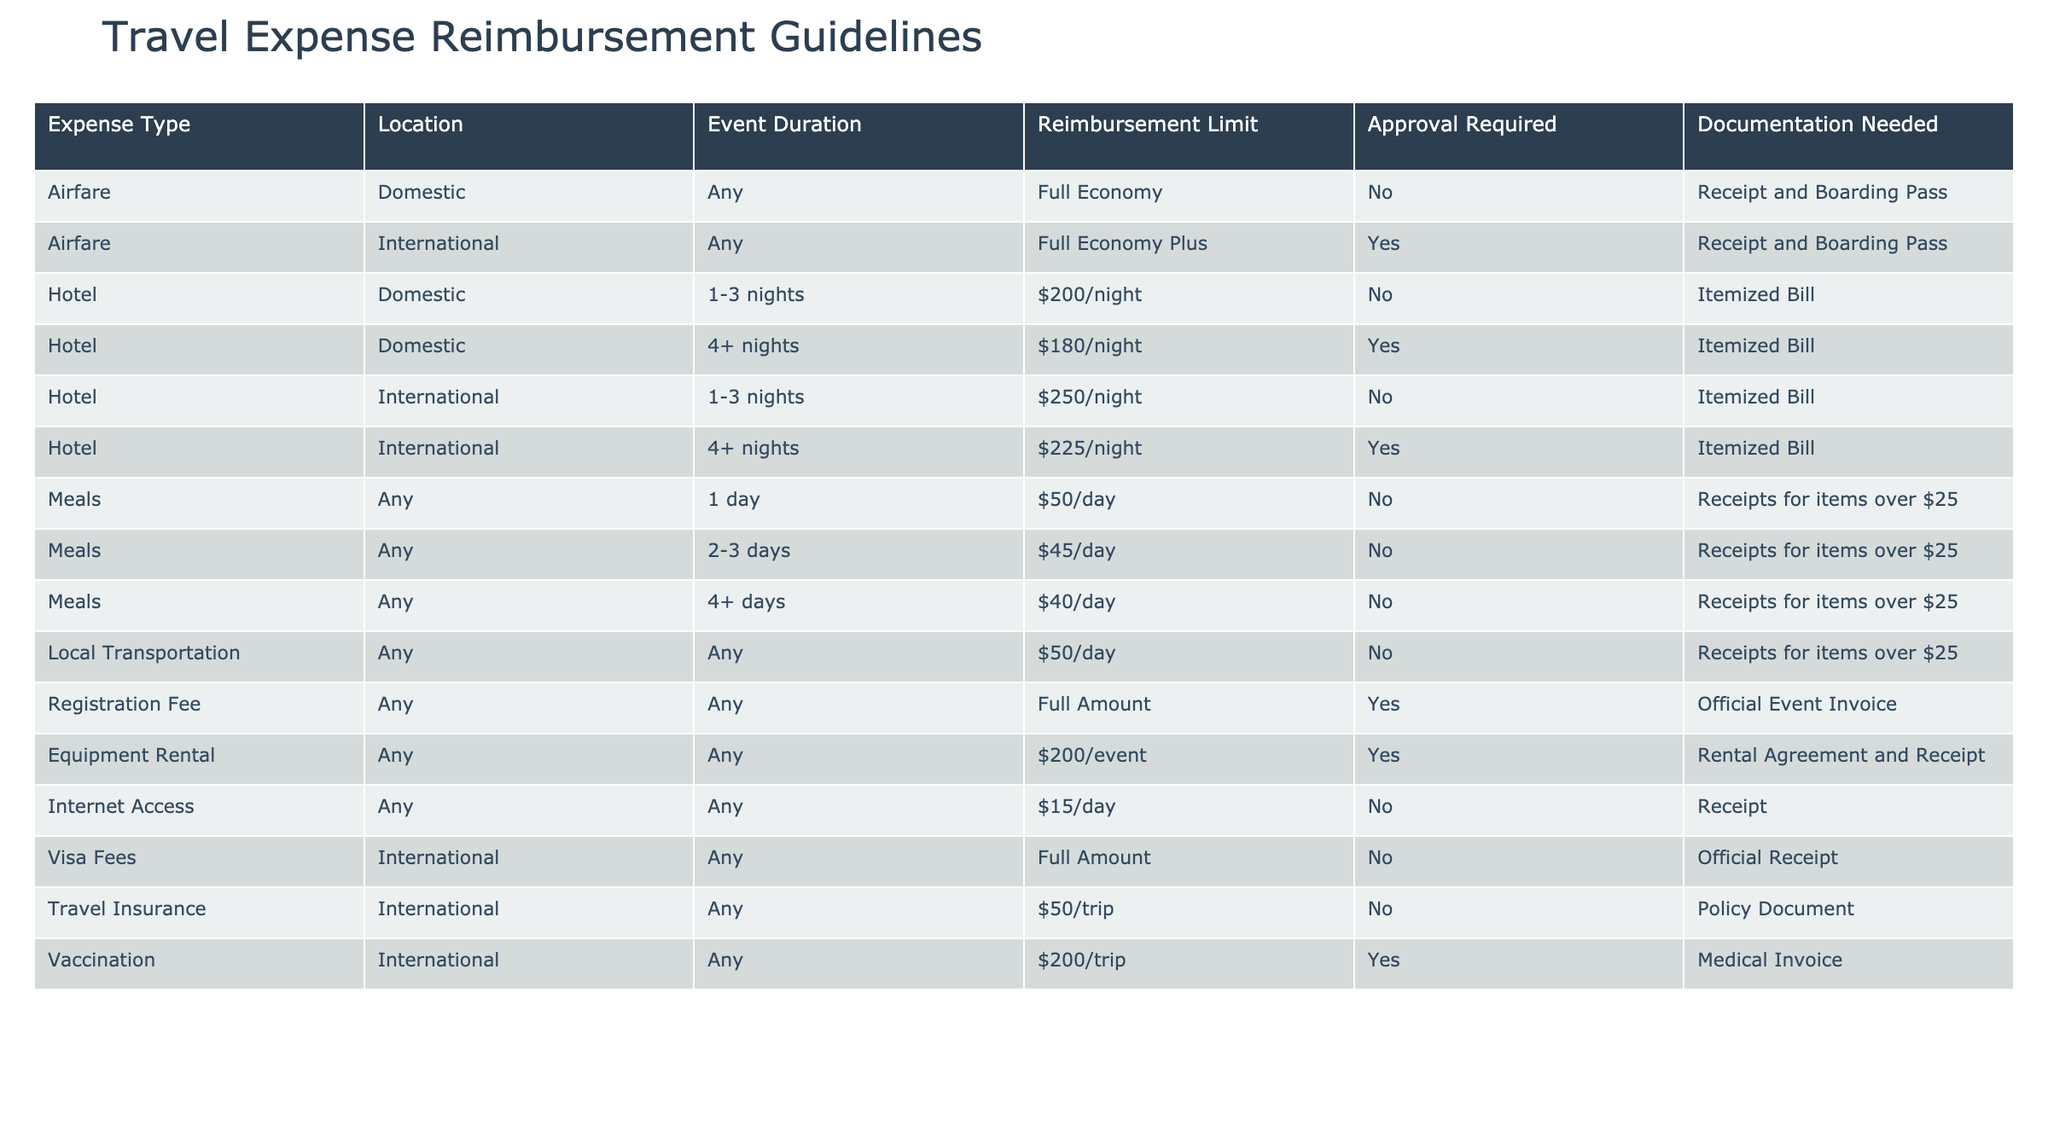What is the maximum reimbursement limit for airfare on domestic flights? According to the table, the reimbursement limit for domestic airfare is "Full Economy" for any duration. Therefore, this is the maximum reimbursement limit.
Answer: Full Economy Is approval required for hotel expenses incurred during a stay of 5 nights domestically? The table states that for hotel stays of 4+ nights domestically, approval is required. Since 5 nights falls into this category, approval is indeed required.
Answer: Yes What is the reimbursement limit for meals over a duration of 3 days? The table outlines that for meals lasting 2-3 days, the limit is $45 per day, and for meals lasting 4 or more days, the limit is $40 per day. Therefore, for a duration of 3 days, the appropriate limit is $45.
Answer: $45/day If a coder attends an international event for 2 days, what is the total maximum reimbursement for meals? The table shows that for any duration of 1 day, the reimbursement limit is $50/day. Since for 2-3 days it is $45/day, the maximum reimbursement for meals over 2 days is $45 times 2, which equals $90.
Answer: $90 Is documentation needed for local transportation expenses? The table specifies that local transportation has a reimbursement limit of $50/day and does not require specific approval or documentation for amounts under $25, suggesting that receipts are needed for items over $25.
Answer: Yes What is the reimbursement limit for hotel stays of 2 nights in an international location? The table indicates that for international hotels, if the stay is 1-3 nights, the limit is $250/night. Since 2 nights fall into this category, the reimbursement limit is $250.
Answer: $250/night What is the total maximum reimbursement for a domestic coder attending a hackathon for 4 days, including airfare, hotel, and meals? The coder will get full economy reimbursement for airfare, which is not quantified. For hotel expenses (assuming 4 nights) it will be $180/night, totaling $720. For meals (4+ days), the limit is $40/day, totaling $160. So total maximum reimbursement is not fully calculable, since the airfare is unspecified but is at least $720 + $160 = $880. Thus, the minimum total is $880.
Answer: Minimum $880 Are visa fees required for international travel reimbursement? The table indicates that visa fees for international travel do not require approval and should be submitted with an official receipt. Hence, they are indeed required for reimbursement considerations.
Answer: Yes 